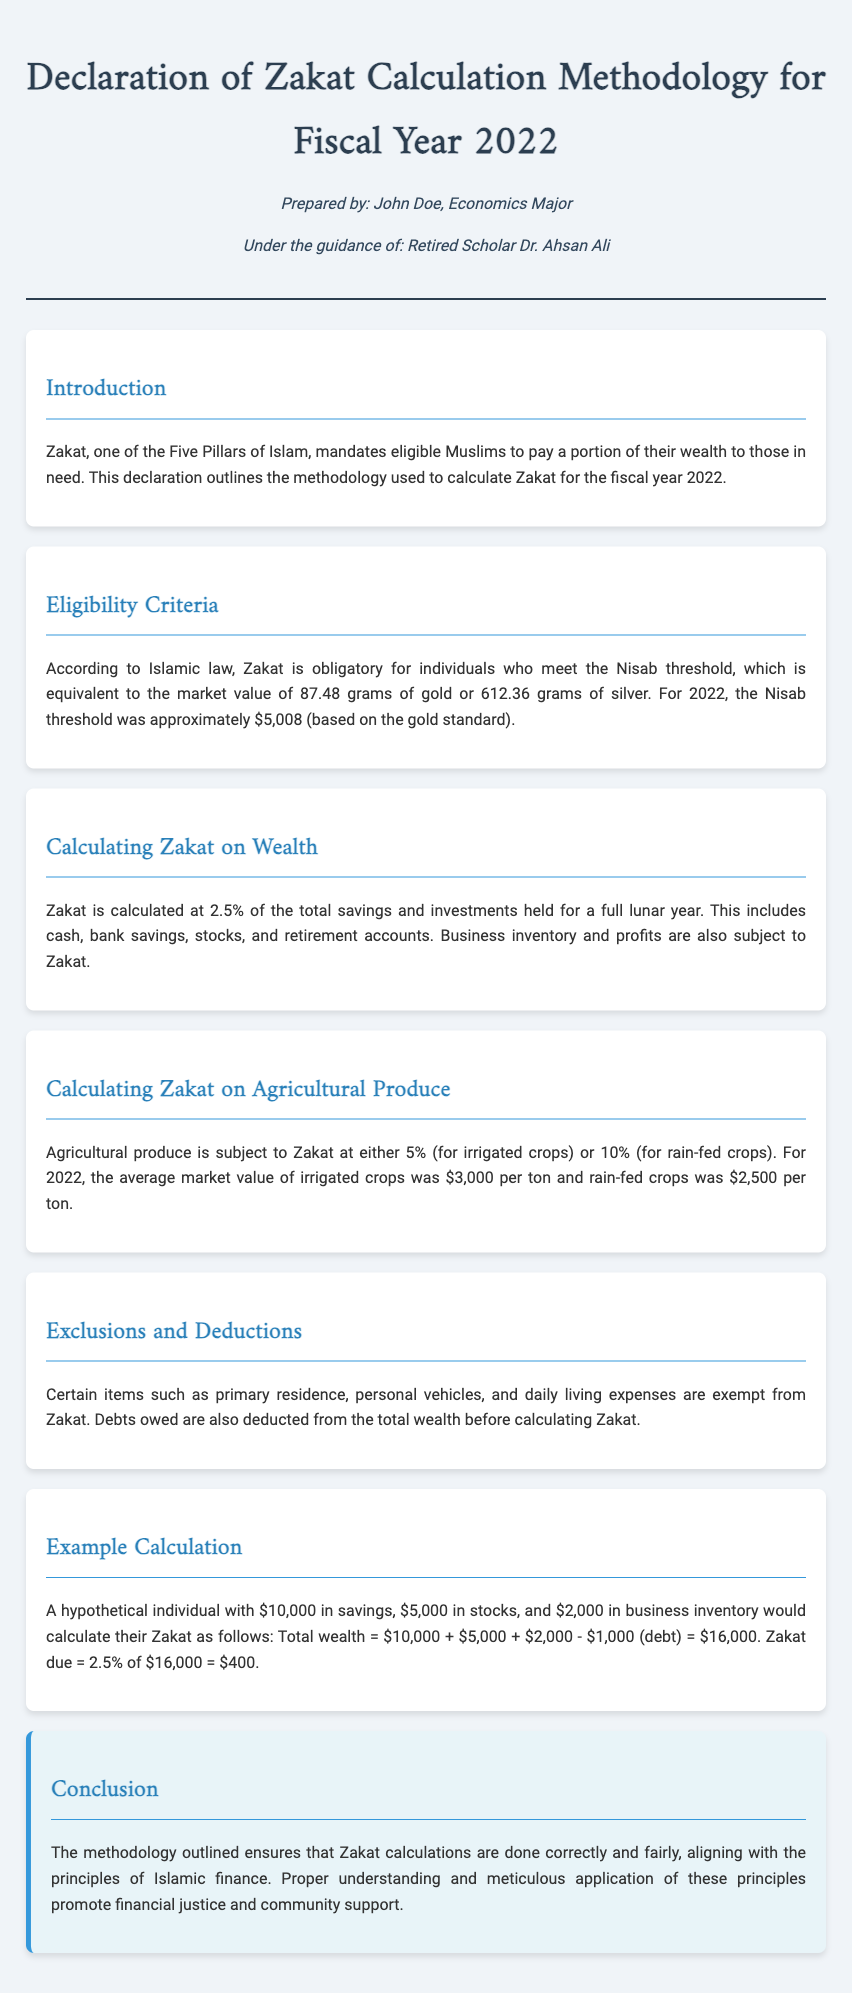What is Zakat? Zakat is one of the Five Pillars of Islam that mandates eligible Muslims to pay a portion of their wealth to those in need.
Answer: portion of their wealth What is the Nisab threshold for 2022? The Nisab threshold is the market value equivalent to 87.48 grams of gold or 612.36 grams of silver, which was approximately $5,008 in 2022.
Answer: $5,008 What is the Zakat rate on wealth? Zakat is calculated at a rate of 2.5% on total savings and investments held for a full lunar year.
Answer: 2.5% What is the Zakat rate for irrigated crops? Agricultural produce is subject to Zakat at either 5% for irrigated crops or 10% for rain-fed crops.
Answer: 5% What are some exclusions from Zakat? Certain items such as primary residence, personal vehicles, and daily living expenses are exempt from Zakat.
Answer: primary residence What does the example calculation total to? The hypothetical individual's total wealth in the example calculation equals $16,000 after accounting for debt.
Answer: $16,000 What is the Zakat due amount in the example calculation? The Zakat due is calculated as 2.5% of the total wealth, which amounts to $400 in the example.
Answer: $400 Who prepared the declaration? The declaration was prepared by John Doe.
Answer: John Doe Who guided the preparation of the declaration? The preparation of the declaration was guided by Retired Scholar Dr. Ahsan Ali.
Answer: Dr. Ahsan Ali 